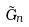Convert formula to latex. <formula><loc_0><loc_0><loc_500><loc_500>\tilde { G } _ { n }</formula> 